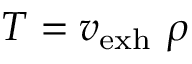Convert formula to latex. <formula><loc_0><loc_0><loc_500><loc_500>T = v _ { e x h } \ \rho</formula> 